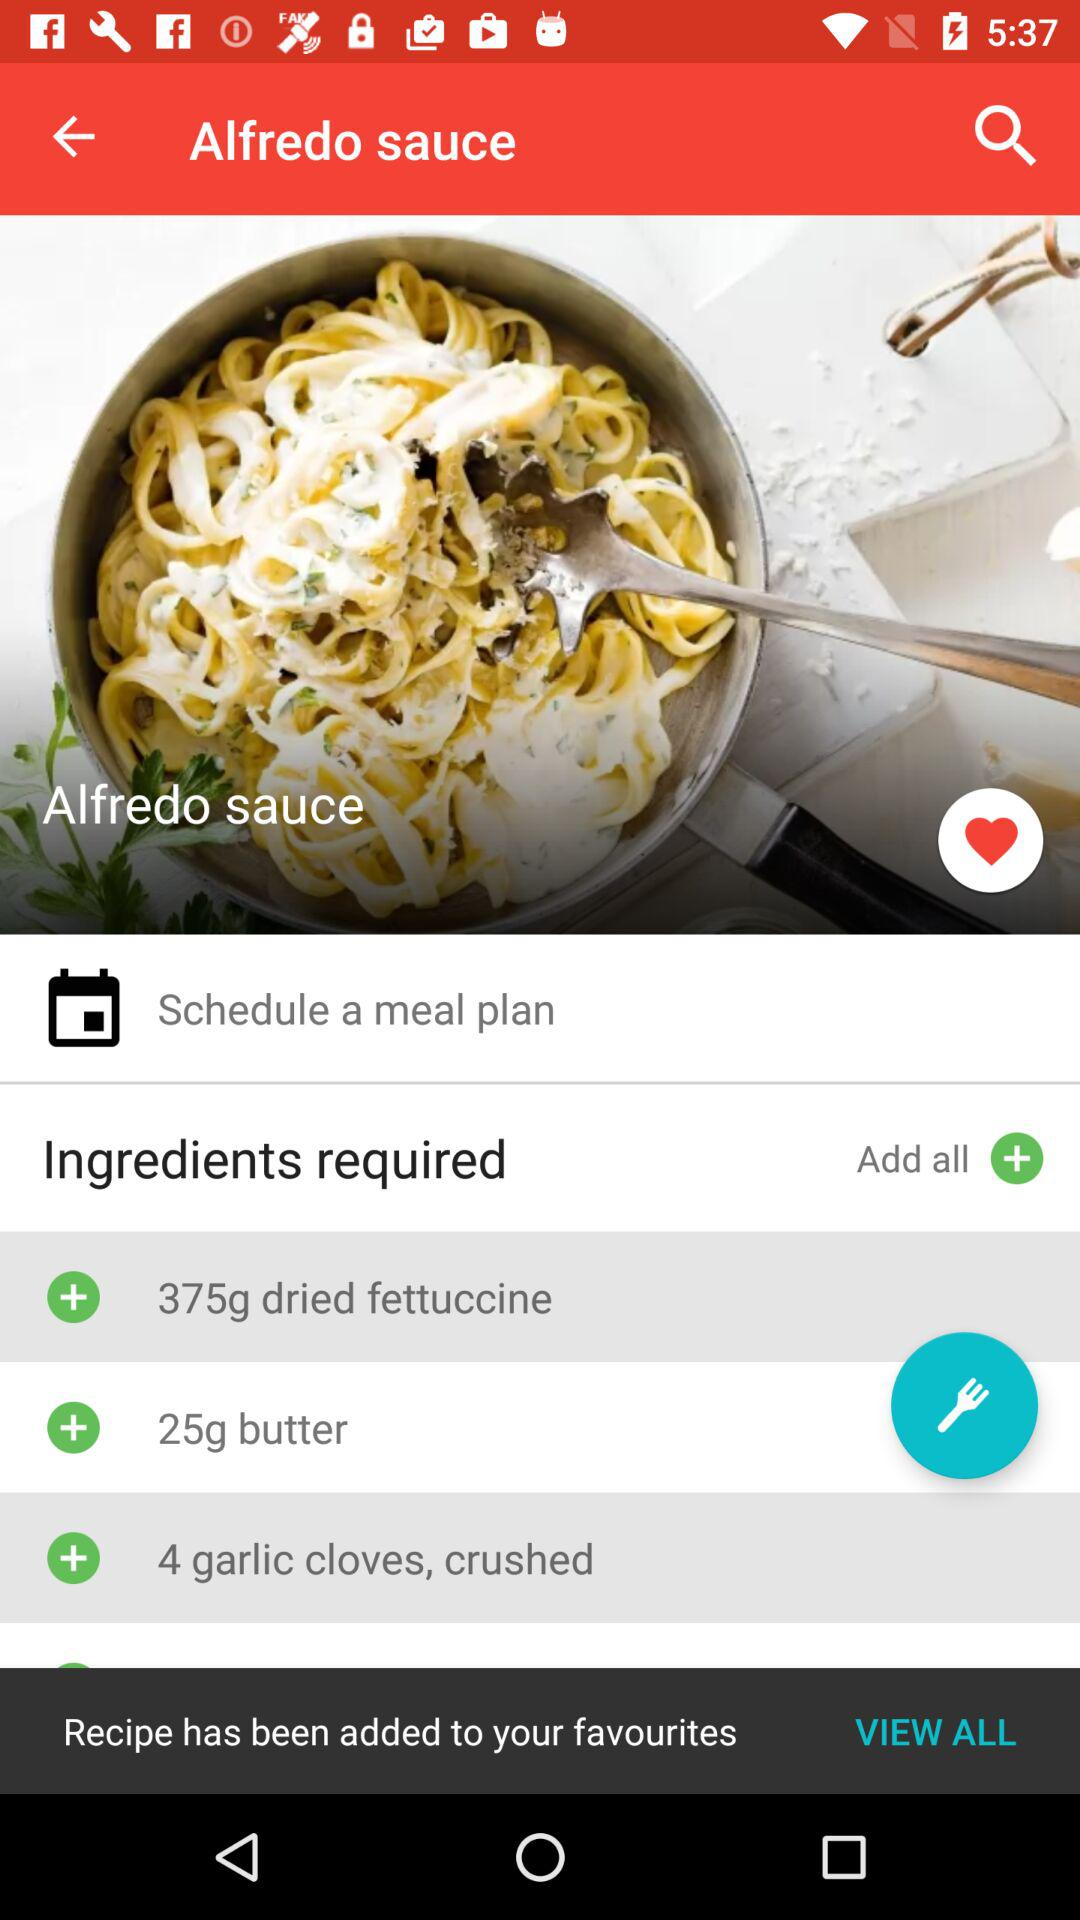What is the name of the dish? The name of the dish is "Alfredo sauce". 